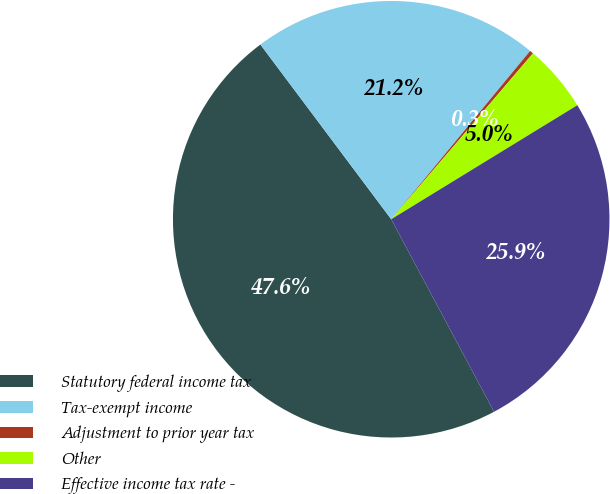Convert chart to OTSL. <chart><loc_0><loc_0><loc_500><loc_500><pie_chart><fcel>Statutory federal income tax<fcel>Tax-exempt income<fcel>Adjustment to prior year tax<fcel>Other<fcel>Effective income tax rate -<nl><fcel>47.58%<fcel>21.21%<fcel>0.27%<fcel>5.0%<fcel>25.94%<nl></chart> 